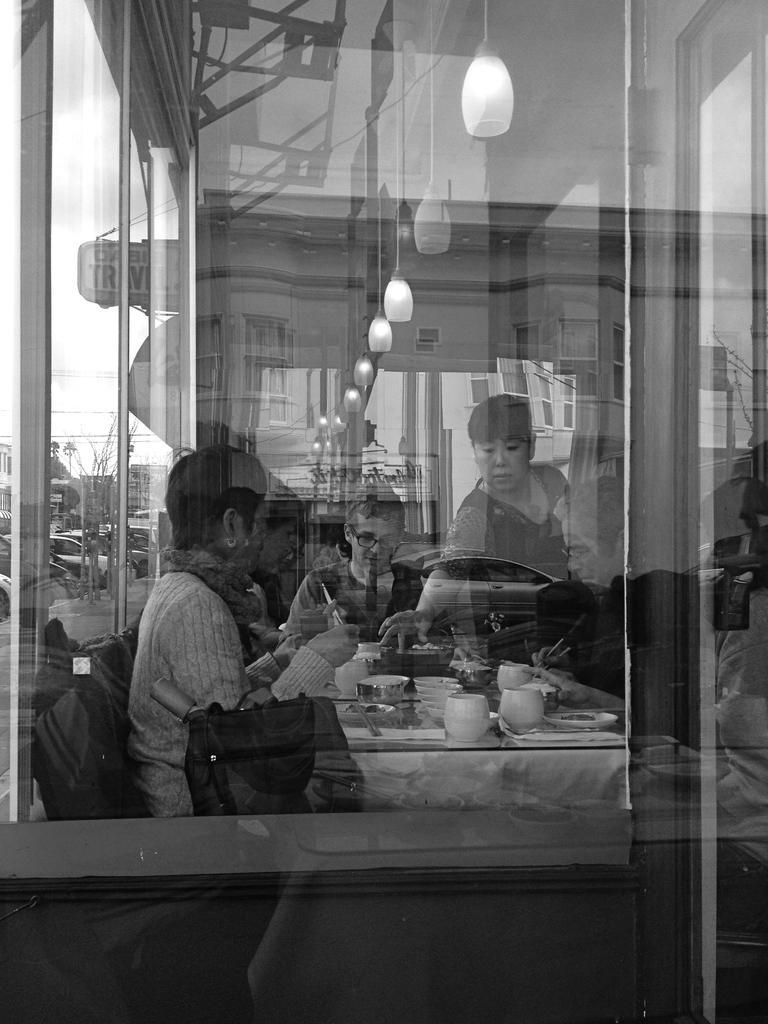How would you summarize this image in a sentence or two? There is a glass. From the glass we can see few persons, table, cups, and plates. There is a bag. Here we can see lights, buildings, cars, and boards. On the glass we can see the reflection of a building. 